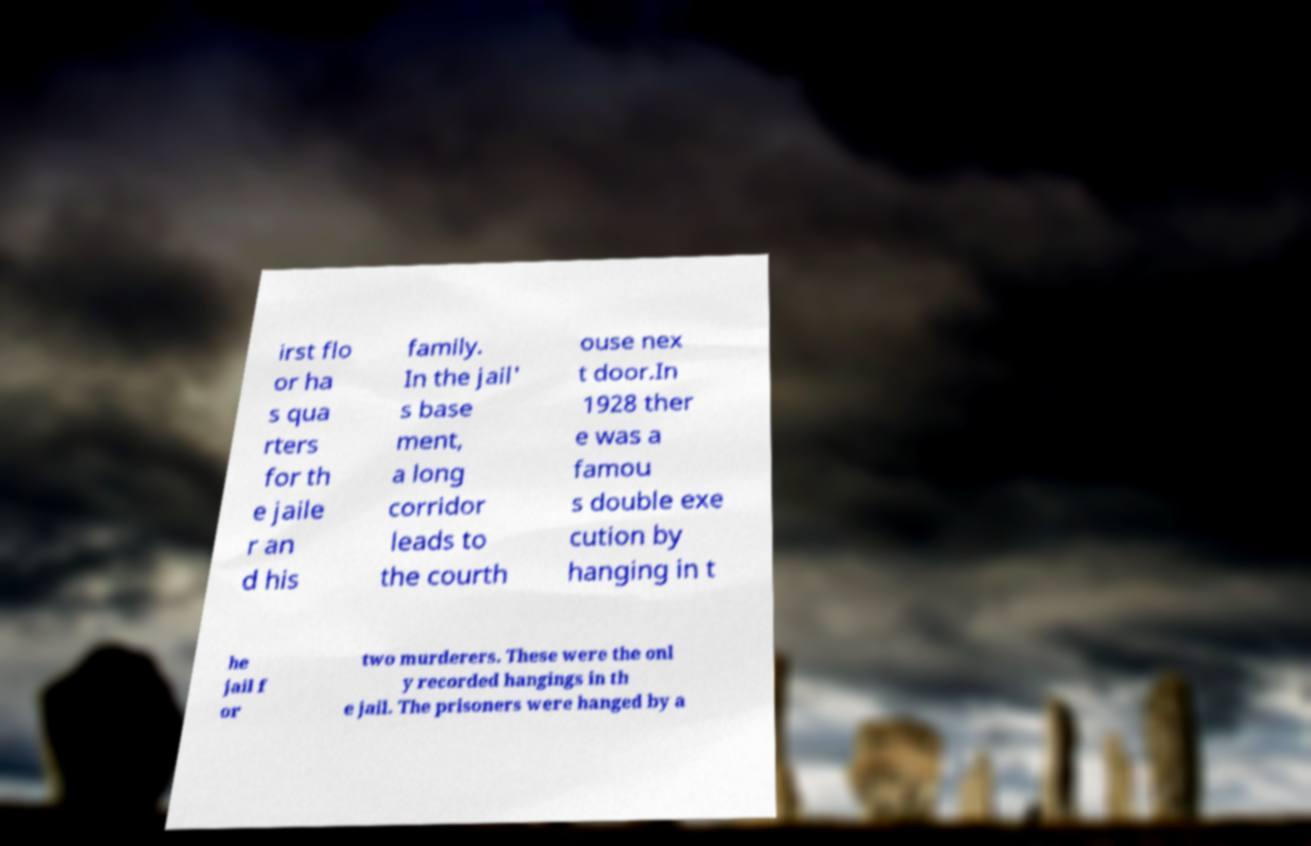Please read and relay the text visible in this image. What does it say? irst flo or ha s qua rters for th e jaile r an d his family. In the jail' s base ment, a long corridor leads to the courth ouse nex t door.In 1928 ther e was a famou s double exe cution by hanging in t he jail f or two murderers. These were the onl y recorded hangings in th e jail. The prisoners were hanged by a 